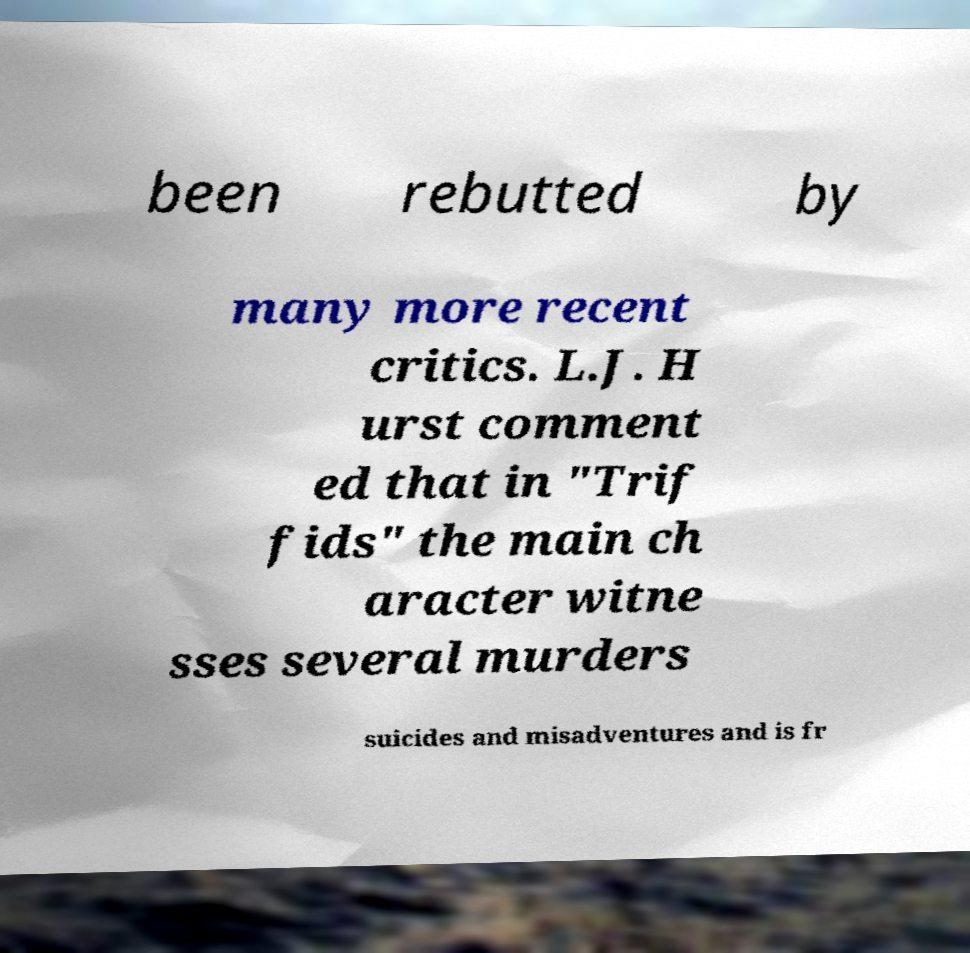For documentation purposes, I need the text within this image transcribed. Could you provide that? been rebutted by many more recent critics. L.J. H urst comment ed that in "Trif fids" the main ch aracter witne sses several murders suicides and misadventures and is fr 